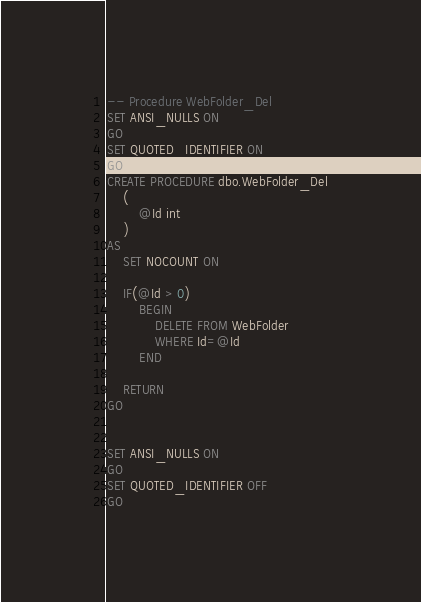Convert code to text. <code><loc_0><loc_0><loc_500><loc_500><_SQL_>
-- Procedure WebFolder_Del
SET ANSI_NULLS ON
GO
SET QUOTED_IDENTIFIER ON
GO
CREATE PROCEDURE dbo.WebFolder_Del
	(
		@Id int
	)
AS
	SET NOCOUNT ON
	
	IF(@Id > 0)
		BEGIN
			DELETE FROM WebFolder 
			WHERE Id=@Id
		END
	
	RETURN
GO


SET ANSI_NULLS ON
GO
SET QUOTED_IDENTIFIER OFF
GO

</code> 